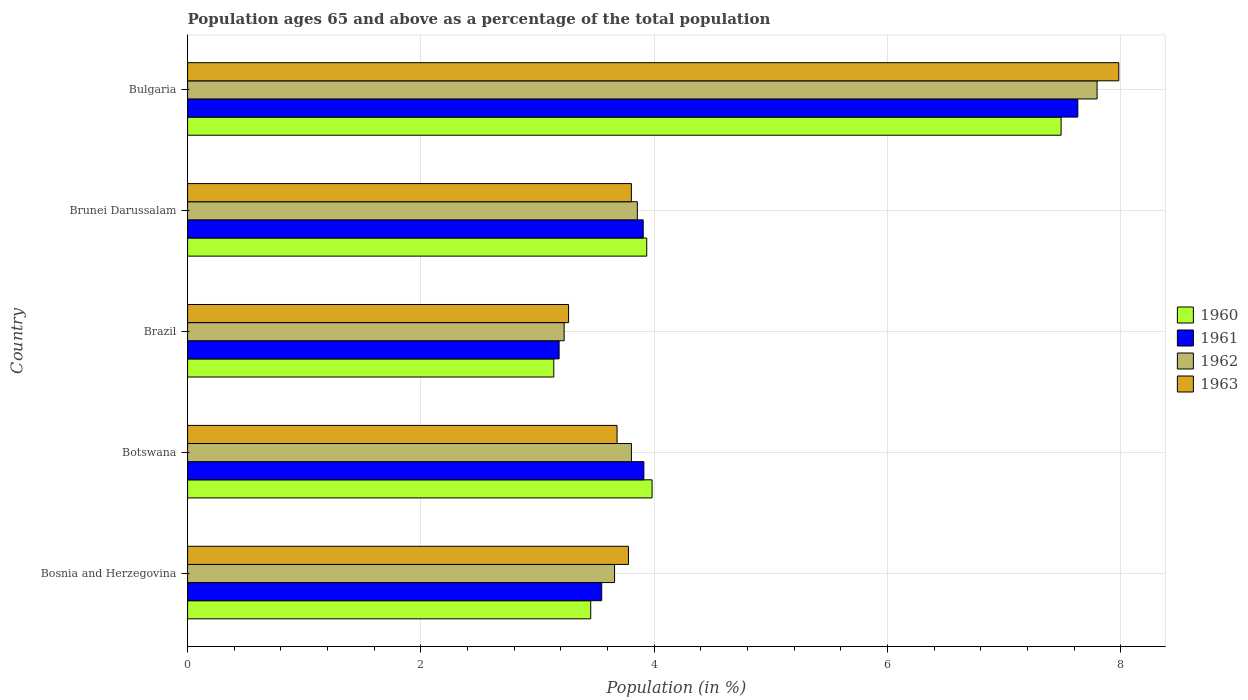Are the number of bars per tick equal to the number of legend labels?
Provide a short and direct response. Yes. How many bars are there on the 2nd tick from the bottom?
Provide a short and direct response. 4. What is the label of the 5th group of bars from the top?
Give a very brief answer. Bosnia and Herzegovina. In how many cases, is the number of bars for a given country not equal to the number of legend labels?
Keep it short and to the point. 0. What is the percentage of the population ages 65 and above in 1962 in Brazil?
Your answer should be compact. 3.23. Across all countries, what is the maximum percentage of the population ages 65 and above in 1961?
Make the answer very short. 7.63. Across all countries, what is the minimum percentage of the population ages 65 and above in 1961?
Offer a very short reply. 3.18. In which country was the percentage of the population ages 65 and above in 1962 minimum?
Make the answer very short. Brazil. What is the total percentage of the population ages 65 and above in 1962 in the graph?
Provide a short and direct response. 22.34. What is the difference between the percentage of the population ages 65 and above in 1961 in Bosnia and Herzegovina and that in Brunei Darussalam?
Provide a short and direct response. -0.36. What is the difference between the percentage of the population ages 65 and above in 1962 in Botswana and the percentage of the population ages 65 and above in 1963 in Brazil?
Your answer should be very brief. 0.54. What is the average percentage of the population ages 65 and above in 1961 per country?
Offer a terse response. 4.44. What is the difference between the percentage of the population ages 65 and above in 1962 and percentage of the population ages 65 and above in 1961 in Brunei Darussalam?
Give a very brief answer. -0.05. What is the ratio of the percentage of the population ages 65 and above in 1960 in Brazil to that in Bulgaria?
Your answer should be compact. 0.42. Is the percentage of the population ages 65 and above in 1960 in Brazil less than that in Brunei Darussalam?
Offer a very short reply. Yes. Is the difference between the percentage of the population ages 65 and above in 1962 in Bosnia and Herzegovina and Botswana greater than the difference between the percentage of the population ages 65 and above in 1961 in Bosnia and Herzegovina and Botswana?
Your answer should be compact. Yes. What is the difference between the highest and the second highest percentage of the population ages 65 and above in 1963?
Your answer should be very brief. 4.18. What is the difference between the highest and the lowest percentage of the population ages 65 and above in 1963?
Provide a succinct answer. 4.72. Is the sum of the percentage of the population ages 65 and above in 1963 in Bosnia and Herzegovina and Brazil greater than the maximum percentage of the population ages 65 and above in 1961 across all countries?
Your answer should be compact. No. How many countries are there in the graph?
Your response must be concise. 5. Does the graph contain any zero values?
Your answer should be very brief. No. Does the graph contain grids?
Give a very brief answer. Yes. How many legend labels are there?
Make the answer very short. 4. How are the legend labels stacked?
Make the answer very short. Vertical. What is the title of the graph?
Your response must be concise. Population ages 65 and above as a percentage of the total population. What is the label or title of the Y-axis?
Offer a terse response. Country. What is the Population (in %) in 1960 in Bosnia and Herzegovina?
Keep it short and to the point. 3.46. What is the Population (in %) of 1961 in Bosnia and Herzegovina?
Provide a succinct answer. 3.55. What is the Population (in %) in 1962 in Bosnia and Herzegovina?
Offer a very short reply. 3.66. What is the Population (in %) of 1963 in Bosnia and Herzegovina?
Offer a terse response. 3.78. What is the Population (in %) in 1960 in Botswana?
Offer a very short reply. 3.98. What is the Population (in %) in 1961 in Botswana?
Ensure brevity in your answer.  3.91. What is the Population (in %) in 1962 in Botswana?
Offer a terse response. 3.8. What is the Population (in %) of 1963 in Botswana?
Ensure brevity in your answer.  3.68. What is the Population (in %) of 1960 in Brazil?
Your response must be concise. 3.14. What is the Population (in %) of 1961 in Brazil?
Provide a short and direct response. 3.18. What is the Population (in %) in 1962 in Brazil?
Ensure brevity in your answer.  3.23. What is the Population (in %) of 1963 in Brazil?
Ensure brevity in your answer.  3.27. What is the Population (in %) in 1960 in Brunei Darussalam?
Give a very brief answer. 3.94. What is the Population (in %) of 1961 in Brunei Darussalam?
Your answer should be compact. 3.9. What is the Population (in %) of 1962 in Brunei Darussalam?
Provide a succinct answer. 3.85. What is the Population (in %) in 1963 in Brunei Darussalam?
Provide a succinct answer. 3.8. What is the Population (in %) of 1960 in Bulgaria?
Your response must be concise. 7.49. What is the Population (in %) in 1961 in Bulgaria?
Keep it short and to the point. 7.63. What is the Population (in %) in 1962 in Bulgaria?
Offer a very short reply. 7.8. What is the Population (in %) of 1963 in Bulgaria?
Offer a terse response. 7.98. Across all countries, what is the maximum Population (in %) of 1960?
Make the answer very short. 7.49. Across all countries, what is the maximum Population (in %) of 1961?
Provide a succinct answer. 7.63. Across all countries, what is the maximum Population (in %) of 1962?
Ensure brevity in your answer.  7.8. Across all countries, what is the maximum Population (in %) in 1963?
Keep it short and to the point. 7.98. Across all countries, what is the minimum Population (in %) of 1960?
Your response must be concise. 3.14. Across all countries, what is the minimum Population (in %) of 1961?
Keep it short and to the point. 3.18. Across all countries, what is the minimum Population (in %) of 1962?
Keep it short and to the point. 3.23. Across all countries, what is the minimum Population (in %) in 1963?
Offer a terse response. 3.27. What is the total Population (in %) of 1960 in the graph?
Make the answer very short. 22. What is the total Population (in %) in 1961 in the graph?
Offer a very short reply. 22.18. What is the total Population (in %) in 1962 in the graph?
Provide a succinct answer. 22.34. What is the total Population (in %) of 1963 in the graph?
Offer a very short reply. 22.51. What is the difference between the Population (in %) in 1960 in Bosnia and Herzegovina and that in Botswana?
Provide a succinct answer. -0.53. What is the difference between the Population (in %) of 1961 in Bosnia and Herzegovina and that in Botswana?
Keep it short and to the point. -0.36. What is the difference between the Population (in %) of 1962 in Bosnia and Herzegovina and that in Botswana?
Offer a terse response. -0.14. What is the difference between the Population (in %) in 1963 in Bosnia and Herzegovina and that in Botswana?
Your answer should be very brief. 0.1. What is the difference between the Population (in %) in 1960 in Bosnia and Herzegovina and that in Brazil?
Your answer should be compact. 0.32. What is the difference between the Population (in %) of 1961 in Bosnia and Herzegovina and that in Brazil?
Ensure brevity in your answer.  0.37. What is the difference between the Population (in %) of 1962 in Bosnia and Herzegovina and that in Brazil?
Provide a succinct answer. 0.43. What is the difference between the Population (in %) in 1963 in Bosnia and Herzegovina and that in Brazil?
Make the answer very short. 0.51. What is the difference between the Population (in %) in 1960 in Bosnia and Herzegovina and that in Brunei Darussalam?
Your answer should be compact. -0.48. What is the difference between the Population (in %) of 1961 in Bosnia and Herzegovina and that in Brunei Darussalam?
Provide a succinct answer. -0.36. What is the difference between the Population (in %) in 1962 in Bosnia and Herzegovina and that in Brunei Darussalam?
Ensure brevity in your answer.  -0.2. What is the difference between the Population (in %) of 1963 in Bosnia and Herzegovina and that in Brunei Darussalam?
Your answer should be compact. -0.02. What is the difference between the Population (in %) of 1960 in Bosnia and Herzegovina and that in Bulgaria?
Ensure brevity in your answer.  -4.03. What is the difference between the Population (in %) of 1961 in Bosnia and Herzegovina and that in Bulgaria?
Your response must be concise. -4.08. What is the difference between the Population (in %) in 1962 in Bosnia and Herzegovina and that in Bulgaria?
Make the answer very short. -4.14. What is the difference between the Population (in %) in 1963 in Bosnia and Herzegovina and that in Bulgaria?
Give a very brief answer. -4.2. What is the difference between the Population (in %) in 1960 in Botswana and that in Brazil?
Keep it short and to the point. 0.84. What is the difference between the Population (in %) in 1961 in Botswana and that in Brazil?
Offer a terse response. 0.73. What is the difference between the Population (in %) of 1962 in Botswana and that in Brazil?
Provide a succinct answer. 0.58. What is the difference between the Population (in %) of 1963 in Botswana and that in Brazil?
Ensure brevity in your answer.  0.42. What is the difference between the Population (in %) of 1960 in Botswana and that in Brunei Darussalam?
Offer a very short reply. 0.05. What is the difference between the Population (in %) in 1961 in Botswana and that in Brunei Darussalam?
Your answer should be compact. 0.01. What is the difference between the Population (in %) of 1962 in Botswana and that in Brunei Darussalam?
Give a very brief answer. -0.05. What is the difference between the Population (in %) of 1963 in Botswana and that in Brunei Darussalam?
Your answer should be compact. -0.12. What is the difference between the Population (in %) in 1960 in Botswana and that in Bulgaria?
Your answer should be very brief. -3.51. What is the difference between the Population (in %) of 1961 in Botswana and that in Bulgaria?
Offer a very short reply. -3.72. What is the difference between the Population (in %) of 1962 in Botswana and that in Bulgaria?
Provide a short and direct response. -3.99. What is the difference between the Population (in %) of 1963 in Botswana and that in Bulgaria?
Offer a terse response. -4.3. What is the difference between the Population (in %) in 1960 in Brazil and that in Brunei Darussalam?
Offer a terse response. -0.8. What is the difference between the Population (in %) of 1961 in Brazil and that in Brunei Darussalam?
Offer a terse response. -0.72. What is the difference between the Population (in %) of 1962 in Brazil and that in Brunei Darussalam?
Your response must be concise. -0.63. What is the difference between the Population (in %) in 1963 in Brazil and that in Brunei Darussalam?
Offer a very short reply. -0.54. What is the difference between the Population (in %) of 1960 in Brazil and that in Bulgaria?
Provide a succinct answer. -4.35. What is the difference between the Population (in %) of 1961 in Brazil and that in Bulgaria?
Your answer should be compact. -4.45. What is the difference between the Population (in %) in 1962 in Brazil and that in Bulgaria?
Your response must be concise. -4.57. What is the difference between the Population (in %) in 1963 in Brazil and that in Bulgaria?
Your answer should be compact. -4.72. What is the difference between the Population (in %) in 1960 in Brunei Darussalam and that in Bulgaria?
Your answer should be very brief. -3.55. What is the difference between the Population (in %) in 1961 in Brunei Darussalam and that in Bulgaria?
Give a very brief answer. -3.73. What is the difference between the Population (in %) of 1962 in Brunei Darussalam and that in Bulgaria?
Your response must be concise. -3.94. What is the difference between the Population (in %) of 1963 in Brunei Darussalam and that in Bulgaria?
Your response must be concise. -4.18. What is the difference between the Population (in %) of 1960 in Bosnia and Herzegovina and the Population (in %) of 1961 in Botswana?
Give a very brief answer. -0.46. What is the difference between the Population (in %) in 1960 in Bosnia and Herzegovina and the Population (in %) in 1962 in Botswana?
Give a very brief answer. -0.35. What is the difference between the Population (in %) in 1960 in Bosnia and Herzegovina and the Population (in %) in 1963 in Botswana?
Offer a very short reply. -0.23. What is the difference between the Population (in %) in 1961 in Bosnia and Herzegovina and the Population (in %) in 1962 in Botswana?
Offer a terse response. -0.25. What is the difference between the Population (in %) in 1961 in Bosnia and Herzegovina and the Population (in %) in 1963 in Botswana?
Keep it short and to the point. -0.13. What is the difference between the Population (in %) of 1962 in Bosnia and Herzegovina and the Population (in %) of 1963 in Botswana?
Your answer should be compact. -0.02. What is the difference between the Population (in %) of 1960 in Bosnia and Herzegovina and the Population (in %) of 1961 in Brazil?
Keep it short and to the point. 0.27. What is the difference between the Population (in %) of 1960 in Bosnia and Herzegovina and the Population (in %) of 1962 in Brazil?
Your answer should be very brief. 0.23. What is the difference between the Population (in %) in 1960 in Bosnia and Herzegovina and the Population (in %) in 1963 in Brazil?
Provide a succinct answer. 0.19. What is the difference between the Population (in %) in 1961 in Bosnia and Herzegovina and the Population (in %) in 1962 in Brazil?
Make the answer very short. 0.32. What is the difference between the Population (in %) in 1961 in Bosnia and Herzegovina and the Population (in %) in 1963 in Brazil?
Provide a succinct answer. 0.28. What is the difference between the Population (in %) in 1962 in Bosnia and Herzegovina and the Population (in %) in 1963 in Brazil?
Your response must be concise. 0.39. What is the difference between the Population (in %) in 1960 in Bosnia and Herzegovina and the Population (in %) in 1961 in Brunei Darussalam?
Provide a short and direct response. -0.45. What is the difference between the Population (in %) of 1960 in Bosnia and Herzegovina and the Population (in %) of 1962 in Brunei Darussalam?
Your answer should be compact. -0.4. What is the difference between the Population (in %) of 1960 in Bosnia and Herzegovina and the Population (in %) of 1963 in Brunei Darussalam?
Offer a very short reply. -0.35. What is the difference between the Population (in %) of 1961 in Bosnia and Herzegovina and the Population (in %) of 1962 in Brunei Darussalam?
Your response must be concise. -0.31. What is the difference between the Population (in %) in 1961 in Bosnia and Herzegovina and the Population (in %) in 1963 in Brunei Darussalam?
Make the answer very short. -0.25. What is the difference between the Population (in %) of 1962 in Bosnia and Herzegovina and the Population (in %) of 1963 in Brunei Darussalam?
Provide a short and direct response. -0.14. What is the difference between the Population (in %) in 1960 in Bosnia and Herzegovina and the Population (in %) in 1961 in Bulgaria?
Provide a succinct answer. -4.18. What is the difference between the Population (in %) in 1960 in Bosnia and Herzegovina and the Population (in %) in 1962 in Bulgaria?
Ensure brevity in your answer.  -4.34. What is the difference between the Population (in %) of 1960 in Bosnia and Herzegovina and the Population (in %) of 1963 in Bulgaria?
Your response must be concise. -4.53. What is the difference between the Population (in %) in 1961 in Bosnia and Herzegovina and the Population (in %) in 1962 in Bulgaria?
Your response must be concise. -4.25. What is the difference between the Population (in %) in 1961 in Bosnia and Herzegovina and the Population (in %) in 1963 in Bulgaria?
Offer a very short reply. -4.43. What is the difference between the Population (in %) of 1962 in Bosnia and Herzegovina and the Population (in %) of 1963 in Bulgaria?
Offer a very short reply. -4.32. What is the difference between the Population (in %) in 1960 in Botswana and the Population (in %) in 1961 in Brazil?
Offer a terse response. 0.8. What is the difference between the Population (in %) of 1960 in Botswana and the Population (in %) of 1962 in Brazil?
Your answer should be very brief. 0.75. What is the difference between the Population (in %) of 1960 in Botswana and the Population (in %) of 1963 in Brazil?
Your answer should be very brief. 0.72. What is the difference between the Population (in %) of 1961 in Botswana and the Population (in %) of 1962 in Brazil?
Provide a succinct answer. 0.68. What is the difference between the Population (in %) of 1961 in Botswana and the Population (in %) of 1963 in Brazil?
Make the answer very short. 0.65. What is the difference between the Population (in %) in 1962 in Botswana and the Population (in %) in 1963 in Brazil?
Provide a short and direct response. 0.54. What is the difference between the Population (in %) in 1960 in Botswana and the Population (in %) in 1961 in Brunei Darussalam?
Offer a terse response. 0.08. What is the difference between the Population (in %) in 1960 in Botswana and the Population (in %) in 1962 in Brunei Darussalam?
Ensure brevity in your answer.  0.13. What is the difference between the Population (in %) of 1960 in Botswana and the Population (in %) of 1963 in Brunei Darussalam?
Your answer should be compact. 0.18. What is the difference between the Population (in %) in 1961 in Botswana and the Population (in %) in 1962 in Brunei Darussalam?
Offer a terse response. 0.06. What is the difference between the Population (in %) of 1961 in Botswana and the Population (in %) of 1963 in Brunei Darussalam?
Your answer should be very brief. 0.11. What is the difference between the Population (in %) in 1960 in Botswana and the Population (in %) in 1961 in Bulgaria?
Your response must be concise. -3.65. What is the difference between the Population (in %) of 1960 in Botswana and the Population (in %) of 1962 in Bulgaria?
Make the answer very short. -3.81. What is the difference between the Population (in %) in 1960 in Botswana and the Population (in %) in 1963 in Bulgaria?
Provide a succinct answer. -4. What is the difference between the Population (in %) of 1961 in Botswana and the Population (in %) of 1962 in Bulgaria?
Ensure brevity in your answer.  -3.88. What is the difference between the Population (in %) in 1961 in Botswana and the Population (in %) in 1963 in Bulgaria?
Your answer should be very brief. -4.07. What is the difference between the Population (in %) in 1962 in Botswana and the Population (in %) in 1963 in Bulgaria?
Your answer should be very brief. -4.18. What is the difference between the Population (in %) of 1960 in Brazil and the Population (in %) of 1961 in Brunei Darussalam?
Ensure brevity in your answer.  -0.77. What is the difference between the Population (in %) in 1960 in Brazil and the Population (in %) in 1962 in Brunei Darussalam?
Your response must be concise. -0.72. What is the difference between the Population (in %) of 1960 in Brazil and the Population (in %) of 1963 in Brunei Darussalam?
Ensure brevity in your answer.  -0.66. What is the difference between the Population (in %) in 1961 in Brazil and the Population (in %) in 1962 in Brunei Darussalam?
Provide a short and direct response. -0.67. What is the difference between the Population (in %) in 1961 in Brazil and the Population (in %) in 1963 in Brunei Darussalam?
Offer a terse response. -0.62. What is the difference between the Population (in %) of 1962 in Brazil and the Population (in %) of 1963 in Brunei Darussalam?
Your response must be concise. -0.58. What is the difference between the Population (in %) of 1960 in Brazil and the Population (in %) of 1961 in Bulgaria?
Your answer should be very brief. -4.49. What is the difference between the Population (in %) in 1960 in Brazil and the Population (in %) in 1962 in Bulgaria?
Offer a very short reply. -4.66. What is the difference between the Population (in %) in 1960 in Brazil and the Population (in %) in 1963 in Bulgaria?
Make the answer very short. -4.84. What is the difference between the Population (in %) in 1961 in Brazil and the Population (in %) in 1962 in Bulgaria?
Give a very brief answer. -4.61. What is the difference between the Population (in %) in 1961 in Brazil and the Population (in %) in 1963 in Bulgaria?
Offer a very short reply. -4.8. What is the difference between the Population (in %) of 1962 in Brazil and the Population (in %) of 1963 in Bulgaria?
Your answer should be very brief. -4.75. What is the difference between the Population (in %) of 1960 in Brunei Darussalam and the Population (in %) of 1961 in Bulgaria?
Offer a very short reply. -3.69. What is the difference between the Population (in %) of 1960 in Brunei Darussalam and the Population (in %) of 1962 in Bulgaria?
Keep it short and to the point. -3.86. What is the difference between the Population (in %) in 1960 in Brunei Darussalam and the Population (in %) in 1963 in Bulgaria?
Provide a succinct answer. -4.05. What is the difference between the Population (in %) in 1961 in Brunei Darussalam and the Population (in %) in 1962 in Bulgaria?
Your response must be concise. -3.89. What is the difference between the Population (in %) of 1961 in Brunei Darussalam and the Population (in %) of 1963 in Bulgaria?
Give a very brief answer. -4.08. What is the difference between the Population (in %) in 1962 in Brunei Darussalam and the Population (in %) in 1963 in Bulgaria?
Offer a terse response. -4.13. What is the average Population (in %) in 1960 per country?
Provide a succinct answer. 4.4. What is the average Population (in %) in 1961 per country?
Provide a succinct answer. 4.44. What is the average Population (in %) in 1962 per country?
Your response must be concise. 4.47. What is the average Population (in %) in 1963 per country?
Provide a short and direct response. 4.5. What is the difference between the Population (in %) in 1960 and Population (in %) in 1961 in Bosnia and Herzegovina?
Your answer should be very brief. -0.09. What is the difference between the Population (in %) of 1960 and Population (in %) of 1962 in Bosnia and Herzegovina?
Give a very brief answer. -0.2. What is the difference between the Population (in %) in 1960 and Population (in %) in 1963 in Bosnia and Herzegovina?
Keep it short and to the point. -0.32. What is the difference between the Population (in %) in 1961 and Population (in %) in 1962 in Bosnia and Herzegovina?
Offer a terse response. -0.11. What is the difference between the Population (in %) in 1961 and Population (in %) in 1963 in Bosnia and Herzegovina?
Ensure brevity in your answer.  -0.23. What is the difference between the Population (in %) of 1962 and Population (in %) of 1963 in Bosnia and Herzegovina?
Your answer should be very brief. -0.12. What is the difference between the Population (in %) in 1960 and Population (in %) in 1961 in Botswana?
Your response must be concise. 0.07. What is the difference between the Population (in %) of 1960 and Population (in %) of 1962 in Botswana?
Your answer should be compact. 0.18. What is the difference between the Population (in %) of 1960 and Population (in %) of 1963 in Botswana?
Your answer should be compact. 0.3. What is the difference between the Population (in %) in 1961 and Population (in %) in 1962 in Botswana?
Offer a terse response. 0.11. What is the difference between the Population (in %) in 1961 and Population (in %) in 1963 in Botswana?
Your answer should be very brief. 0.23. What is the difference between the Population (in %) in 1962 and Population (in %) in 1963 in Botswana?
Provide a short and direct response. 0.12. What is the difference between the Population (in %) in 1960 and Population (in %) in 1961 in Brazil?
Keep it short and to the point. -0.05. What is the difference between the Population (in %) in 1960 and Population (in %) in 1962 in Brazil?
Offer a terse response. -0.09. What is the difference between the Population (in %) of 1960 and Population (in %) of 1963 in Brazil?
Give a very brief answer. -0.13. What is the difference between the Population (in %) in 1961 and Population (in %) in 1962 in Brazil?
Your answer should be compact. -0.04. What is the difference between the Population (in %) of 1961 and Population (in %) of 1963 in Brazil?
Provide a succinct answer. -0.08. What is the difference between the Population (in %) in 1962 and Population (in %) in 1963 in Brazil?
Give a very brief answer. -0.04. What is the difference between the Population (in %) of 1960 and Population (in %) of 1961 in Brunei Darussalam?
Your answer should be very brief. 0.03. What is the difference between the Population (in %) of 1960 and Population (in %) of 1962 in Brunei Darussalam?
Provide a succinct answer. 0.08. What is the difference between the Population (in %) in 1960 and Population (in %) in 1963 in Brunei Darussalam?
Keep it short and to the point. 0.13. What is the difference between the Population (in %) of 1961 and Population (in %) of 1962 in Brunei Darussalam?
Offer a very short reply. 0.05. What is the difference between the Population (in %) of 1961 and Population (in %) of 1963 in Brunei Darussalam?
Provide a succinct answer. 0.1. What is the difference between the Population (in %) of 1962 and Population (in %) of 1963 in Brunei Darussalam?
Offer a very short reply. 0.05. What is the difference between the Population (in %) of 1960 and Population (in %) of 1961 in Bulgaria?
Your answer should be very brief. -0.14. What is the difference between the Population (in %) of 1960 and Population (in %) of 1962 in Bulgaria?
Your answer should be very brief. -0.31. What is the difference between the Population (in %) of 1960 and Population (in %) of 1963 in Bulgaria?
Provide a succinct answer. -0.49. What is the difference between the Population (in %) in 1961 and Population (in %) in 1962 in Bulgaria?
Your answer should be compact. -0.17. What is the difference between the Population (in %) of 1961 and Population (in %) of 1963 in Bulgaria?
Offer a very short reply. -0.35. What is the difference between the Population (in %) in 1962 and Population (in %) in 1963 in Bulgaria?
Ensure brevity in your answer.  -0.19. What is the ratio of the Population (in %) in 1960 in Bosnia and Herzegovina to that in Botswana?
Ensure brevity in your answer.  0.87. What is the ratio of the Population (in %) in 1961 in Bosnia and Herzegovina to that in Botswana?
Provide a short and direct response. 0.91. What is the ratio of the Population (in %) in 1963 in Bosnia and Herzegovina to that in Botswana?
Keep it short and to the point. 1.03. What is the ratio of the Population (in %) in 1960 in Bosnia and Herzegovina to that in Brazil?
Give a very brief answer. 1.1. What is the ratio of the Population (in %) of 1961 in Bosnia and Herzegovina to that in Brazil?
Your answer should be very brief. 1.11. What is the ratio of the Population (in %) in 1962 in Bosnia and Herzegovina to that in Brazil?
Your response must be concise. 1.13. What is the ratio of the Population (in %) in 1963 in Bosnia and Herzegovina to that in Brazil?
Offer a very short reply. 1.16. What is the ratio of the Population (in %) in 1960 in Bosnia and Herzegovina to that in Brunei Darussalam?
Offer a very short reply. 0.88. What is the ratio of the Population (in %) of 1961 in Bosnia and Herzegovina to that in Brunei Darussalam?
Provide a succinct answer. 0.91. What is the ratio of the Population (in %) of 1962 in Bosnia and Herzegovina to that in Brunei Darussalam?
Provide a succinct answer. 0.95. What is the ratio of the Population (in %) in 1963 in Bosnia and Herzegovina to that in Brunei Darussalam?
Offer a terse response. 0.99. What is the ratio of the Population (in %) of 1960 in Bosnia and Herzegovina to that in Bulgaria?
Ensure brevity in your answer.  0.46. What is the ratio of the Population (in %) of 1961 in Bosnia and Herzegovina to that in Bulgaria?
Keep it short and to the point. 0.47. What is the ratio of the Population (in %) of 1962 in Bosnia and Herzegovina to that in Bulgaria?
Ensure brevity in your answer.  0.47. What is the ratio of the Population (in %) of 1963 in Bosnia and Herzegovina to that in Bulgaria?
Your answer should be very brief. 0.47. What is the ratio of the Population (in %) in 1960 in Botswana to that in Brazil?
Give a very brief answer. 1.27. What is the ratio of the Population (in %) of 1961 in Botswana to that in Brazil?
Keep it short and to the point. 1.23. What is the ratio of the Population (in %) in 1962 in Botswana to that in Brazil?
Offer a very short reply. 1.18. What is the ratio of the Population (in %) in 1963 in Botswana to that in Brazil?
Your response must be concise. 1.13. What is the ratio of the Population (in %) of 1960 in Botswana to that in Brunei Darussalam?
Make the answer very short. 1.01. What is the ratio of the Population (in %) of 1961 in Botswana to that in Brunei Darussalam?
Provide a succinct answer. 1. What is the ratio of the Population (in %) of 1963 in Botswana to that in Brunei Darussalam?
Your answer should be very brief. 0.97. What is the ratio of the Population (in %) of 1960 in Botswana to that in Bulgaria?
Make the answer very short. 0.53. What is the ratio of the Population (in %) of 1961 in Botswana to that in Bulgaria?
Make the answer very short. 0.51. What is the ratio of the Population (in %) in 1962 in Botswana to that in Bulgaria?
Provide a succinct answer. 0.49. What is the ratio of the Population (in %) in 1963 in Botswana to that in Bulgaria?
Offer a very short reply. 0.46. What is the ratio of the Population (in %) of 1960 in Brazil to that in Brunei Darussalam?
Give a very brief answer. 0.8. What is the ratio of the Population (in %) of 1961 in Brazil to that in Brunei Darussalam?
Your answer should be compact. 0.82. What is the ratio of the Population (in %) in 1962 in Brazil to that in Brunei Darussalam?
Your answer should be very brief. 0.84. What is the ratio of the Population (in %) in 1963 in Brazil to that in Brunei Darussalam?
Offer a very short reply. 0.86. What is the ratio of the Population (in %) of 1960 in Brazil to that in Bulgaria?
Ensure brevity in your answer.  0.42. What is the ratio of the Population (in %) of 1961 in Brazil to that in Bulgaria?
Your answer should be compact. 0.42. What is the ratio of the Population (in %) of 1962 in Brazil to that in Bulgaria?
Offer a very short reply. 0.41. What is the ratio of the Population (in %) of 1963 in Brazil to that in Bulgaria?
Provide a succinct answer. 0.41. What is the ratio of the Population (in %) in 1960 in Brunei Darussalam to that in Bulgaria?
Provide a short and direct response. 0.53. What is the ratio of the Population (in %) in 1961 in Brunei Darussalam to that in Bulgaria?
Give a very brief answer. 0.51. What is the ratio of the Population (in %) of 1962 in Brunei Darussalam to that in Bulgaria?
Offer a terse response. 0.49. What is the ratio of the Population (in %) in 1963 in Brunei Darussalam to that in Bulgaria?
Provide a succinct answer. 0.48. What is the difference between the highest and the second highest Population (in %) of 1960?
Make the answer very short. 3.51. What is the difference between the highest and the second highest Population (in %) of 1961?
Provide a short and direct response. 3.72. What is the difference between the highest and the second highest Population (in %) of 1962?
Give a very brief answer. 3.94. What is the difference between the highest and the second highest Population (in %) of 1963?
Offer a terse response. 4.18. What is the difference between the highest and the lowest Population (in %) of 1960?
Keep it short and to the point. 4.35. What is the difference between the highest and the lowest Population (in %) in 1961?
Keep it short and to the point. 4.45. What is the difference between the highest and the lowest Population (in %) of 1962?
Your answer should be compact. 4.57. What is the difference between the highest and the lowest Population (in %) of 1963?
Your answer should be very brief. 4.72. 